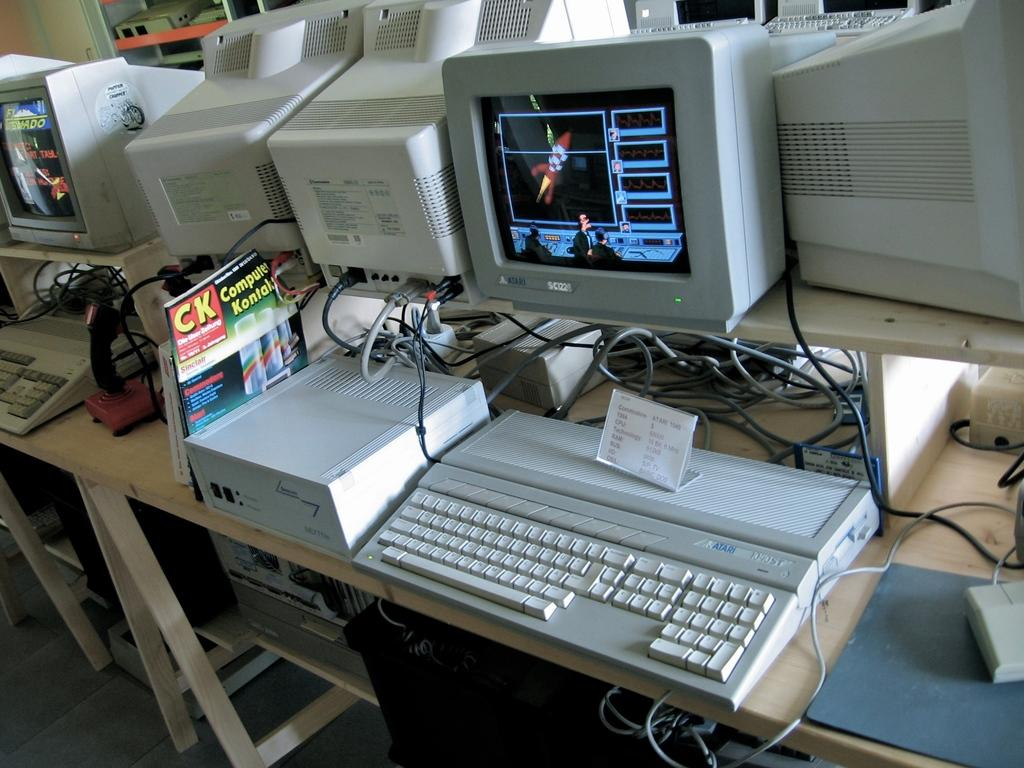Provide a one-sentence caption for the provided image. A computer and keyboard with a CK - Computer Kontal magazine next to it. 